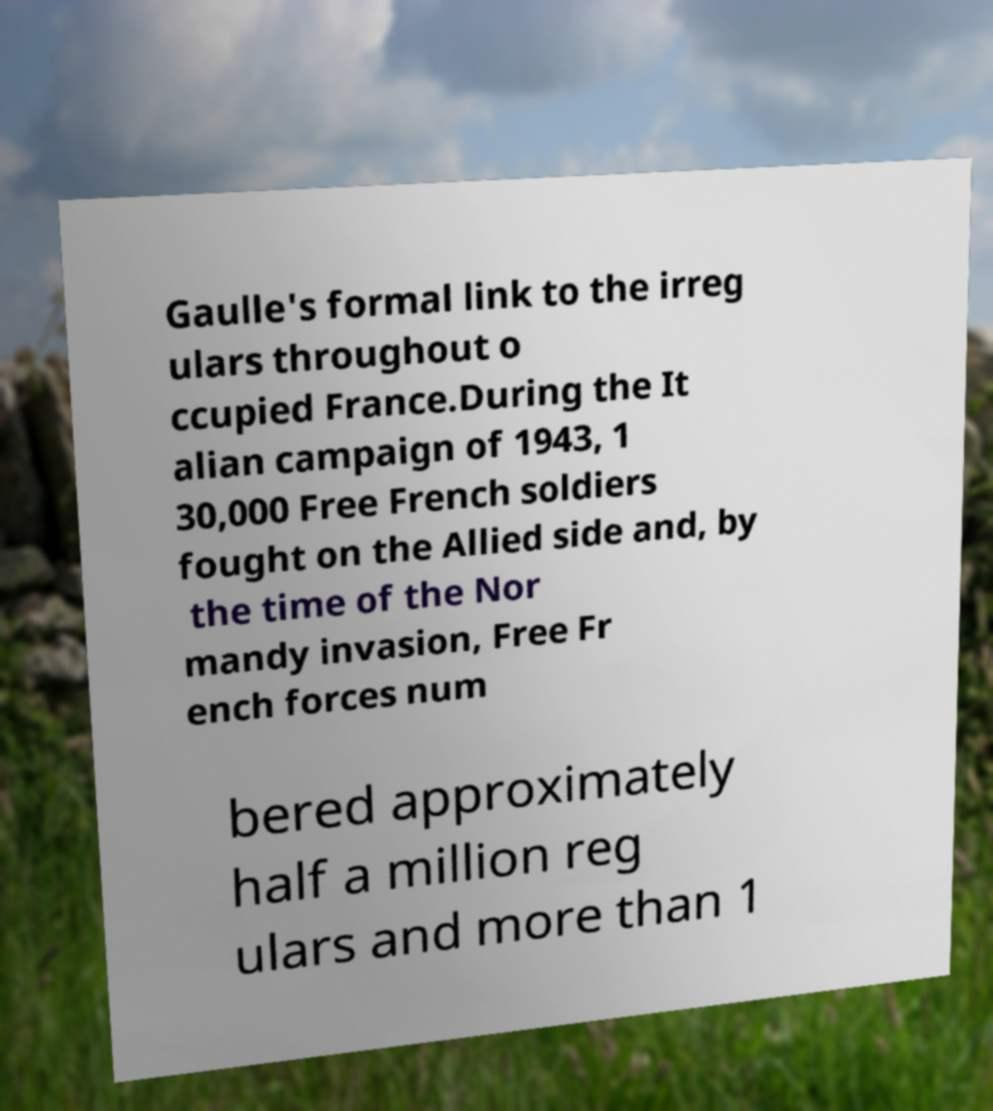What messages or text are displayed in this image? I need them in a readable, typed format. Gaulle's formal link to the irreg ulars throughout o ccupied France.During the It alian campaign of 1943, 1 30,000 Free French soldiers fought on the Allied side and, by the time of the Nor mandy invasion, Free Fr ench forces num bered approximately half a million reg ulars and more than 1 